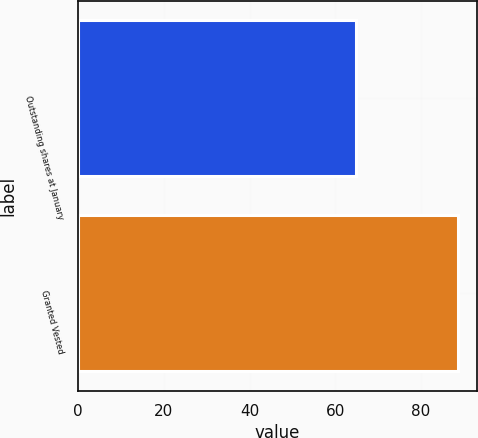Convert chart to OTSL. <chart><loc_0><loc_0><loc_500><loc_500><bar_chart><fcel>Outstanding shares at January<fcel>Granted Vested<nl><fcel>64.82<fcel>88.58<nl></chart> 